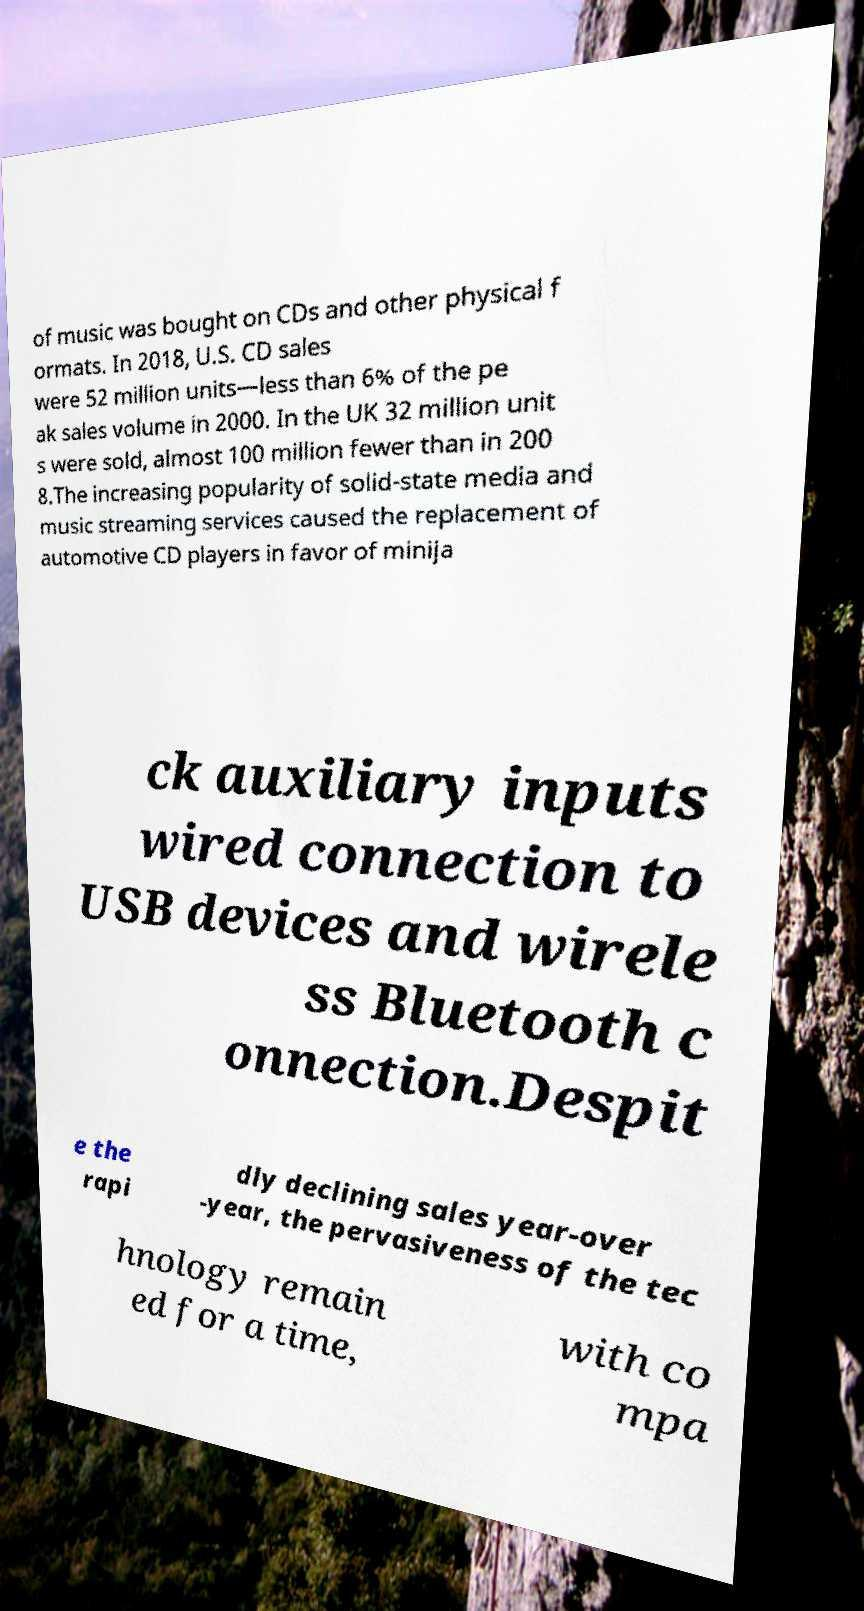What messages or text are displayed in this image? I need them in a readable, typed format. of music was bought on CDs and other physical f ormats. In 2018, U.S. CD sales were 52 million units—less than 6% of the pe ak sales volume in 2000. In the UK 32 million unit s were sold, almost 100 million fewer than in 200 8.The increasing popularity of solid-state media and music streaming services caused the replacement of automotive CD players in favor of minija ck auxiliary inputs wired connection to USB devices and wirele ss Bluetooth c onnection.Despit e the rapi dly declining sales year-over -year, the pervasiveness of the tec hnology remain ed for a time, with co mpa 